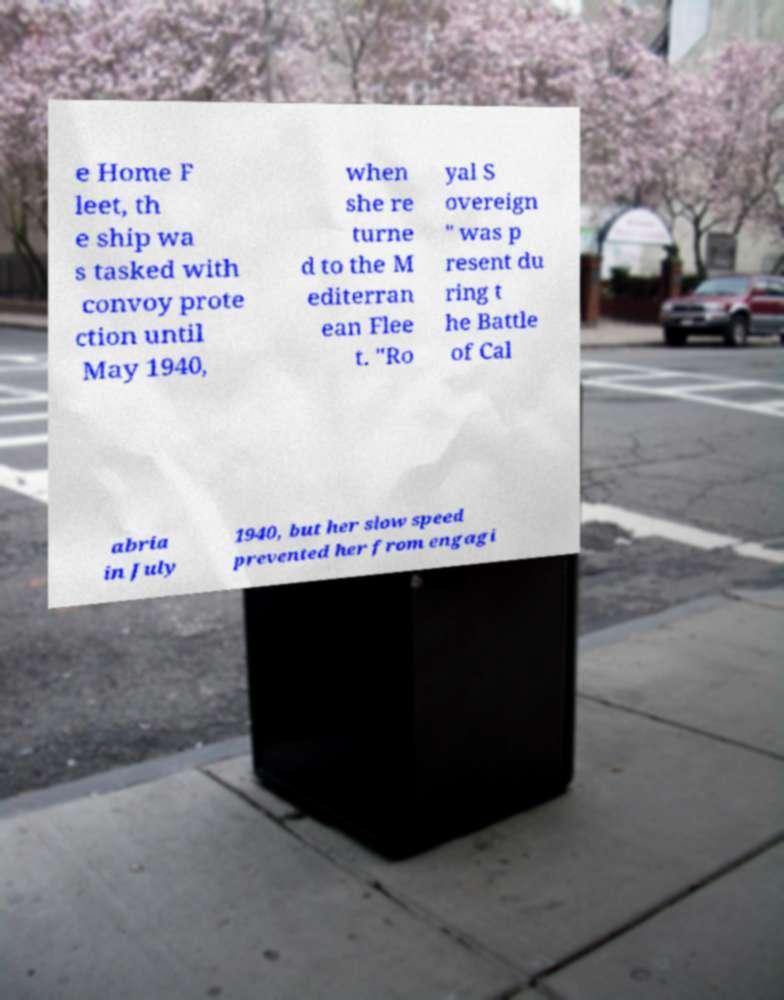Please read and relay the text visible in this image. What does it say? e Home F leet, th e ship wa s tasked with convoy prote ction until May 1940, when she re turne d to the M editerran ean Flee t. "Ro yal S overeign " was p resent du ring t he Battle of Cal abria in July 1940, but her slow speed prevented her from engagi 